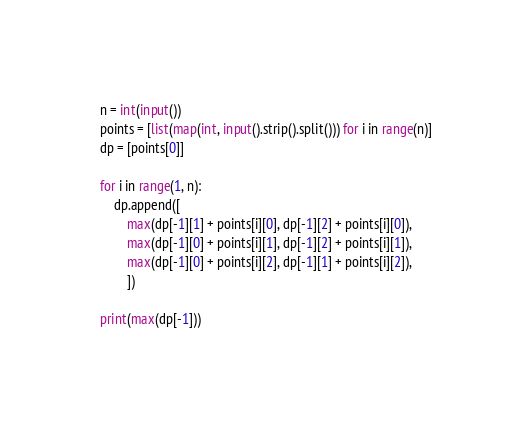<code> <loc_0><loc_0><loc_500><loc_500><_Python_>n = int(input())
points = [list(map(int, input().strip().split())) for i in range(n)]
dp = [points[0]]

for i in range(1, n):
    dp.append([
        max(dp[-1][1] + points[i][0], dp[-1][2] + points[i][0]),
        max(dp[-1][0] + points[i][1], dp[-1][2] + points[i][1]),
        max(dp[-1][0] + points[i][2], dp[-1][1] + points[i][2]),
        ])

print(max(dp[-1]))

</code> 